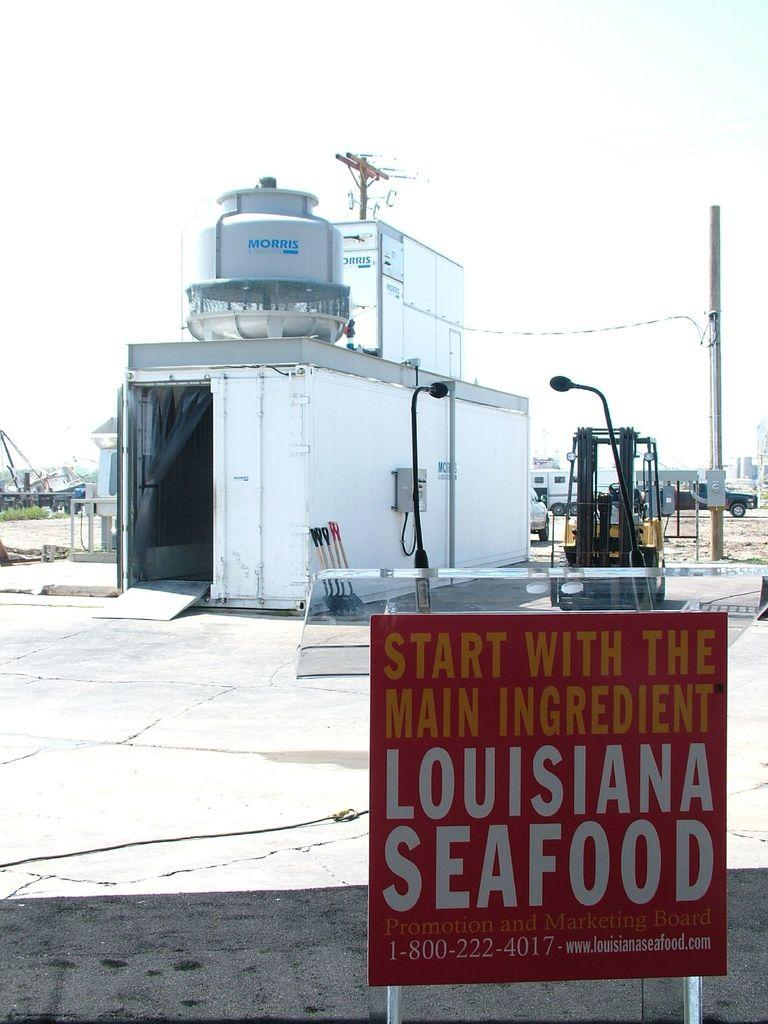<image>
Share a concise interpretation of the image provided. A Louisiana Seafood sign says to start with the main ingredient. 